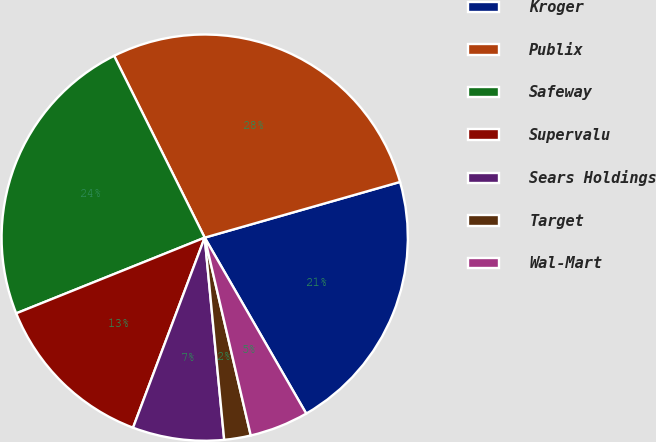Convert chart to OTSL. <chart><loc_0><loc_0><loc_500><loc_500><pie_chart><fcel>Kroger<fcel>Publix<fcel>Safeway<fcel>Supervalu<fcel>Sears Holdings<fcel>Target<fcel>Wal-Mart<nl><fcel>21.09%<fcel>27.94%<fcel>23.72%<fcel>13.18%<fcel>7.27%<fcel>2.11%<fcel>4.69%<nl></chart> 